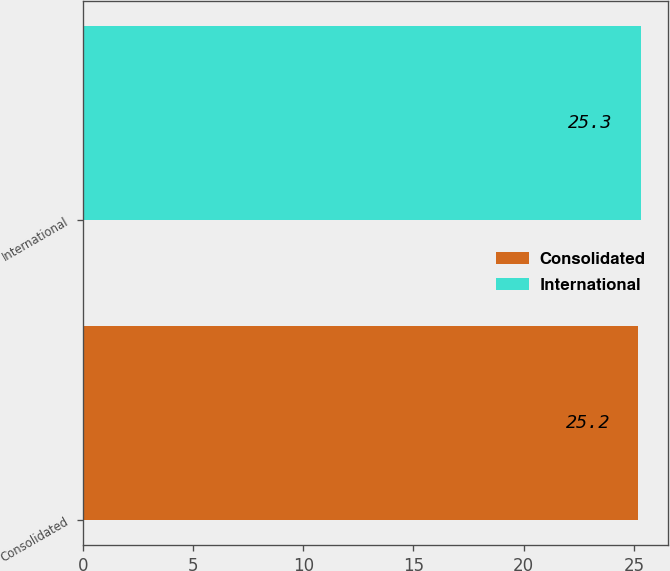<chart> <loc_0><loc_0><loc_500><loc_500><bar_chart><fcel>Consolidated<fcel>International<nl><fcel>25.2<fcel>25.3<nl></chart> 